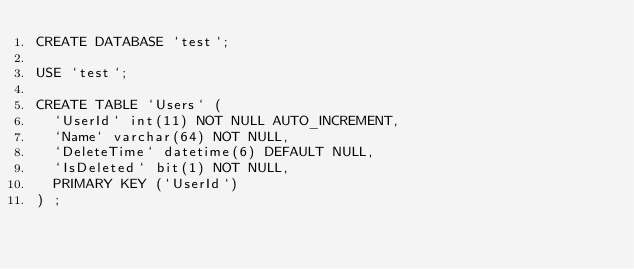Convert code to text. <code><loc_0><loc_0><loc_500><loc_500><_SQL_>CREATE DATABASE `test`;

USE `test`;

CREATE TABLE `Users` (
  `UserId` int(11) NOT NULL AUTO_INCREMENT,
  `Name` varchar(64) NOT NULL,
  `DeleteTime` datetime(6) DEFAULT NULL,
  `IsDeleted` bit(1) NOT NULL,
  PRIMARY KEY (`UserId`)
) ;
</code> 